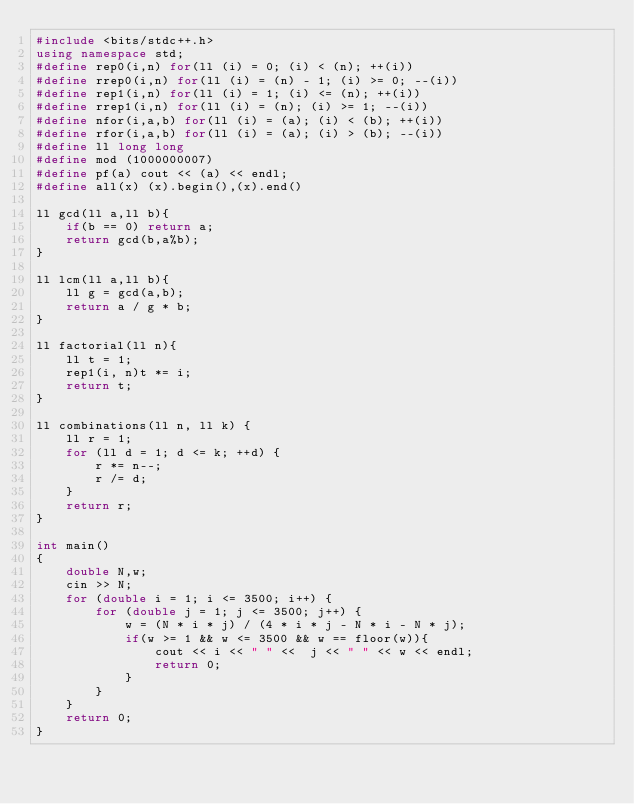<code> <loc_0><loc_0><loc_500><loc_500><_C++_>#include <bits/stdc++.h>
using namespace std;
#define rep0(i,n) for(ll (i) = 0; (i) < (n); ++(i))
#define rrep0(i,n) for(ll (i) = (n) - 1; (i) >= 0; --(i))
#define rep1(i,n) for(ll (i) = 1; (i) <= (n); ++(i))
#define rrep1(i,n) for(ll (i) = (n); (i) >= 1; --(i))
#define nfor(i,a,b) for(ll (i) = (a); (i) < (b); ++(i))
#define rfor(i,a,b) for(ll (i) = (a); (i) > (b); --(i))
#define ll long long
#define mod (1000000007)
#define pf(a) cout << (a) << endl;
#define all(x) (x).begin(),(x).end()

ll gcd(ll a,ll b){
    if(b == 0) return a;
    return gcd(b,a%b);
}

ll lcm(ll a,ll b){
    ll g = gcd(a,b);
    return a / g * b;
}

ll factorial(ll n){
    ll t = 1;
    rep1(i, n)t *= i;
    return t;
}

ll combinations(ll n, ll k) {
    ll r = 1;
    for (ll d = 1; d <= k; ++d) {
        r *= n--;
        r /= d;
    }
    return r;
}

int main()
{
    double N,w;
    cin >> N;
    for (double i = 1; i <= 3500; i++) {
        for (double j = 1; j <= 3500; j++) {
            w = (N * i * j) / (4 * i * j - N * i - N * j);
            if(w >= 1 && w <= 3500 && w == floor(w)){
                cout << i << " " <<  j << " " << w << endl;
                return 0;
            }
        }
    }
    return 0;
}
</code> 